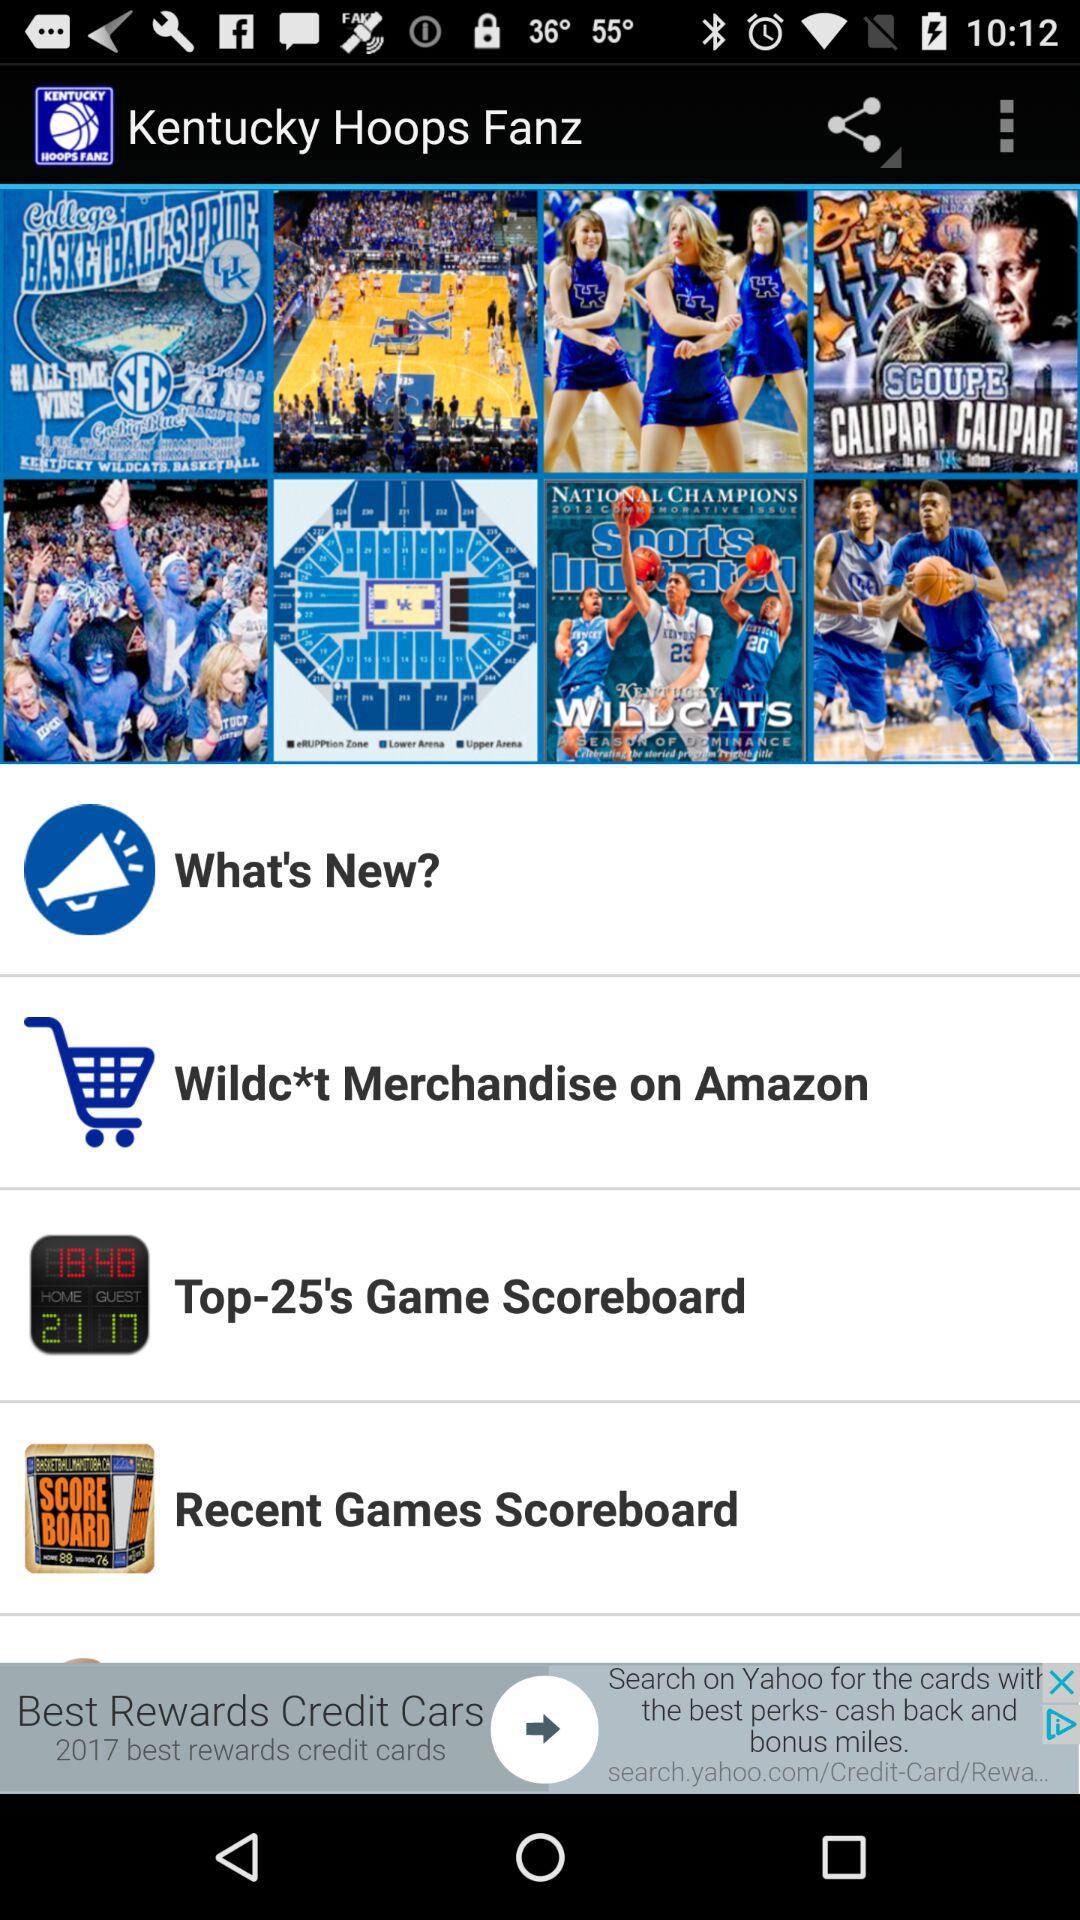What is the application name? The application name is "Kentucky Basketball UK". 